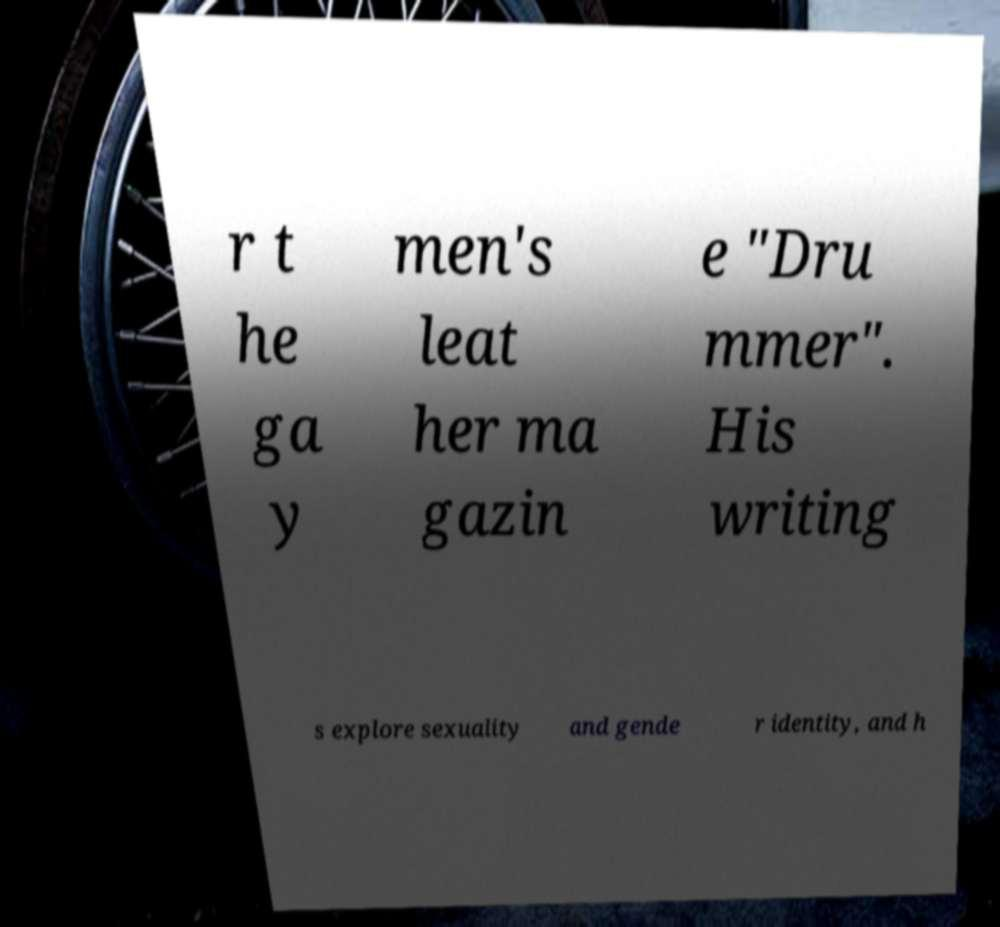Can you read and provide the text displayed in the image?This photo seems to have some interesting text. Can you extract and type it out for me? r t he ga y men's leat her ma gazin e "Dru mmer". His writing s explore sexuality and gende r identity, and h 